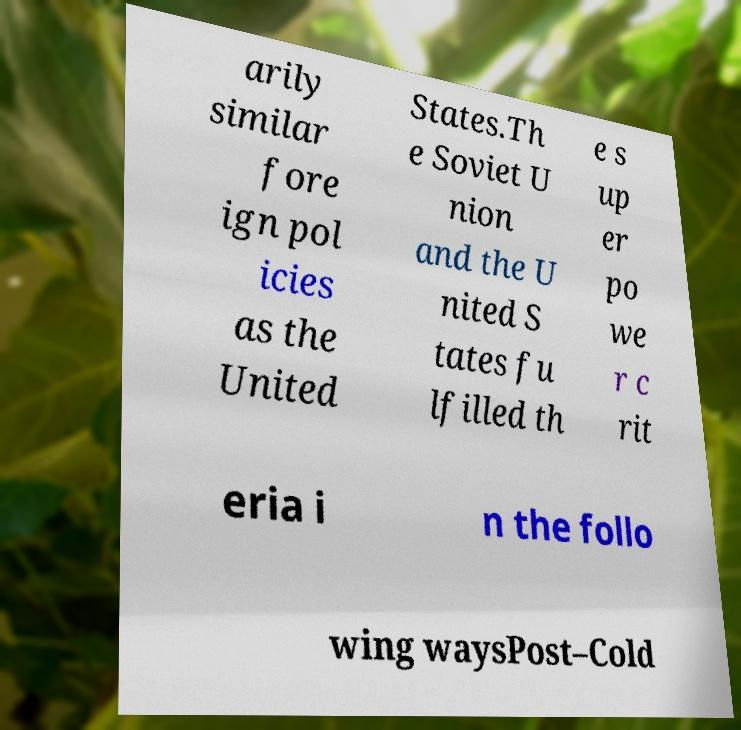Can you accurately transcribe the text from the provided image for me? arily similar fore ign pol icies as the United States.Th e Soviet U nion and the U nited S tates fu lfilled th e s up er po we r c rit eria i n the follo wing waysPost–Cold 